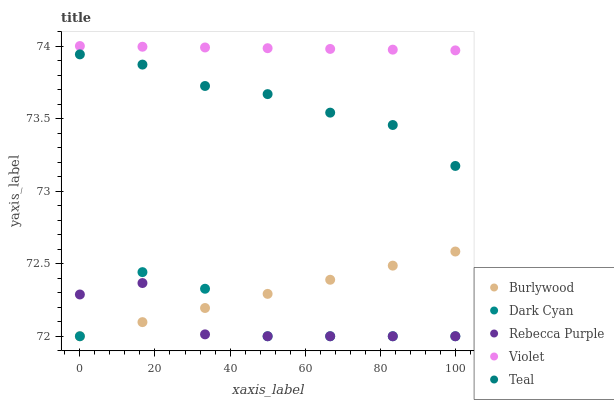Does Rebecca Purple have the minimum area under the curve?
Answer yes or no. Yes. Does Violet have the maximum area under the curve?
Answer yes or no. Yes. Does Dark Cyan have the minimum area under the curve?
Answer yes or no. No. Does Dark Cyan have the maximum area under the curve?
Answer yes or no. No. Is Violet the smoothest?
Answer yes or no. Yes. Is Dark Cyan the roughest?
Answer yes or no. Yes. Is Rebecca Purple the smoothest?
Answer yes or no. No. Is Rebecca Purple the roughest?
Answer yes or no. No. Does Burlywood have the lowest value?
Answer yes or no. Yes. Does Teal have the lowest value?
Answer yes or no. No. Does Violet have the highest value?
Answer yes or no. Yes. Does Dark Cyan have the highest value?
Answer yes or no. No. Is Dark Cyan less than Teal?
Answer yes or no. Yes. Is Violet greater than Rebecca Purple?
Answer yes or no. Yes. Does Burlywood intersect Dark Cyan?
Answer yes or no. Yes. Is Burlywood less than Dark Cyan?
Answer yes or no. No. Is Burlywood greater than Dark Cyan?
Answer yes or no. No. Does Dark Cyan intersect Teal?
Answer yes or no. No. 